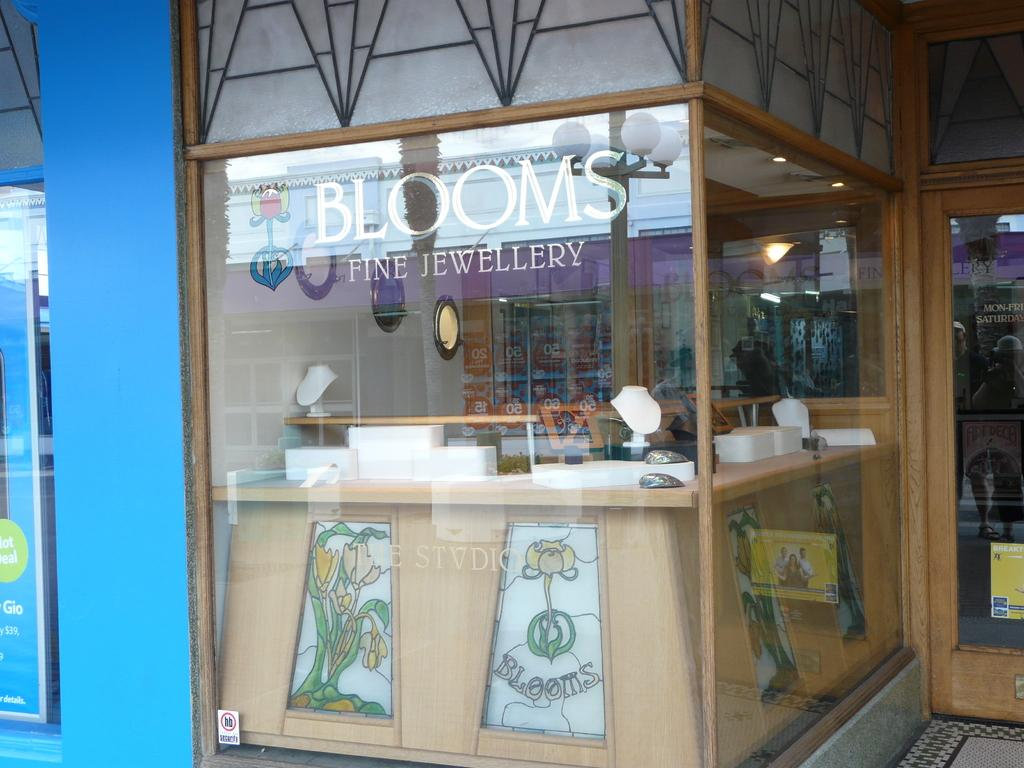<image>
Share a concise interpretation of the image provided. Jewelry stand from the company Blooms that says Fine Jewellery. 